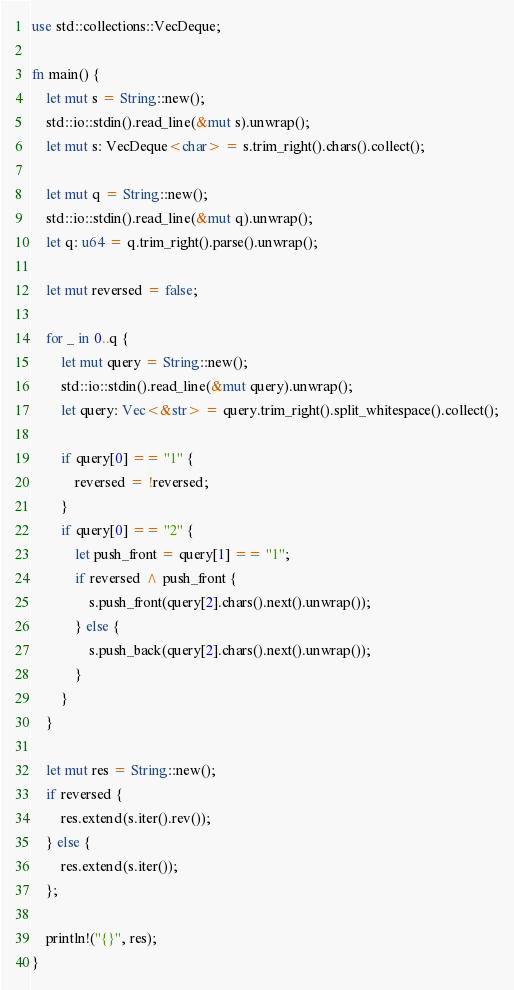Convert code to text. <code><loc_0><loc_0><loc_500><loc_500><_Rust_>use std::collections::VecDeque;

fn main() {
    let mut s = String::new();
    std::io::stdin().read_line(&mut s).unwrap();
    let mut s: VecDeque<char> = s.trim_right().chars().collect();

    let mut q = String::new();
    std::io::stdin().read_line(&mut q).unwrap();
    let q: u64 = q.trim_right().parse().unwrap();

    let mut reversed = false;

    for _ in 0..q {
        let mut query = String::new();
        std::io::stdin().read_line(&mut query).unwrap();
        let query: Vec<&str> = query.trim_right().split_whitespace().collect();

        if query[0] == "1" {
            reversed = !reversed;
        }
        if query[0] == "2" {
            let push_front = query[1] == "1";
            if reversed ^ push_front {
                s.push_front(query[2].chars().next().unwrap());
            } else {
                s.push_back(query[2].chars().next().unwrap());
            }
        }
    }

    let mut res = String::new();
    if reversed {
        res.extend(s.iter().rev());
    } else {
        res.extend(s.iter());
    };

    println!("{}", res);
}
</code> 